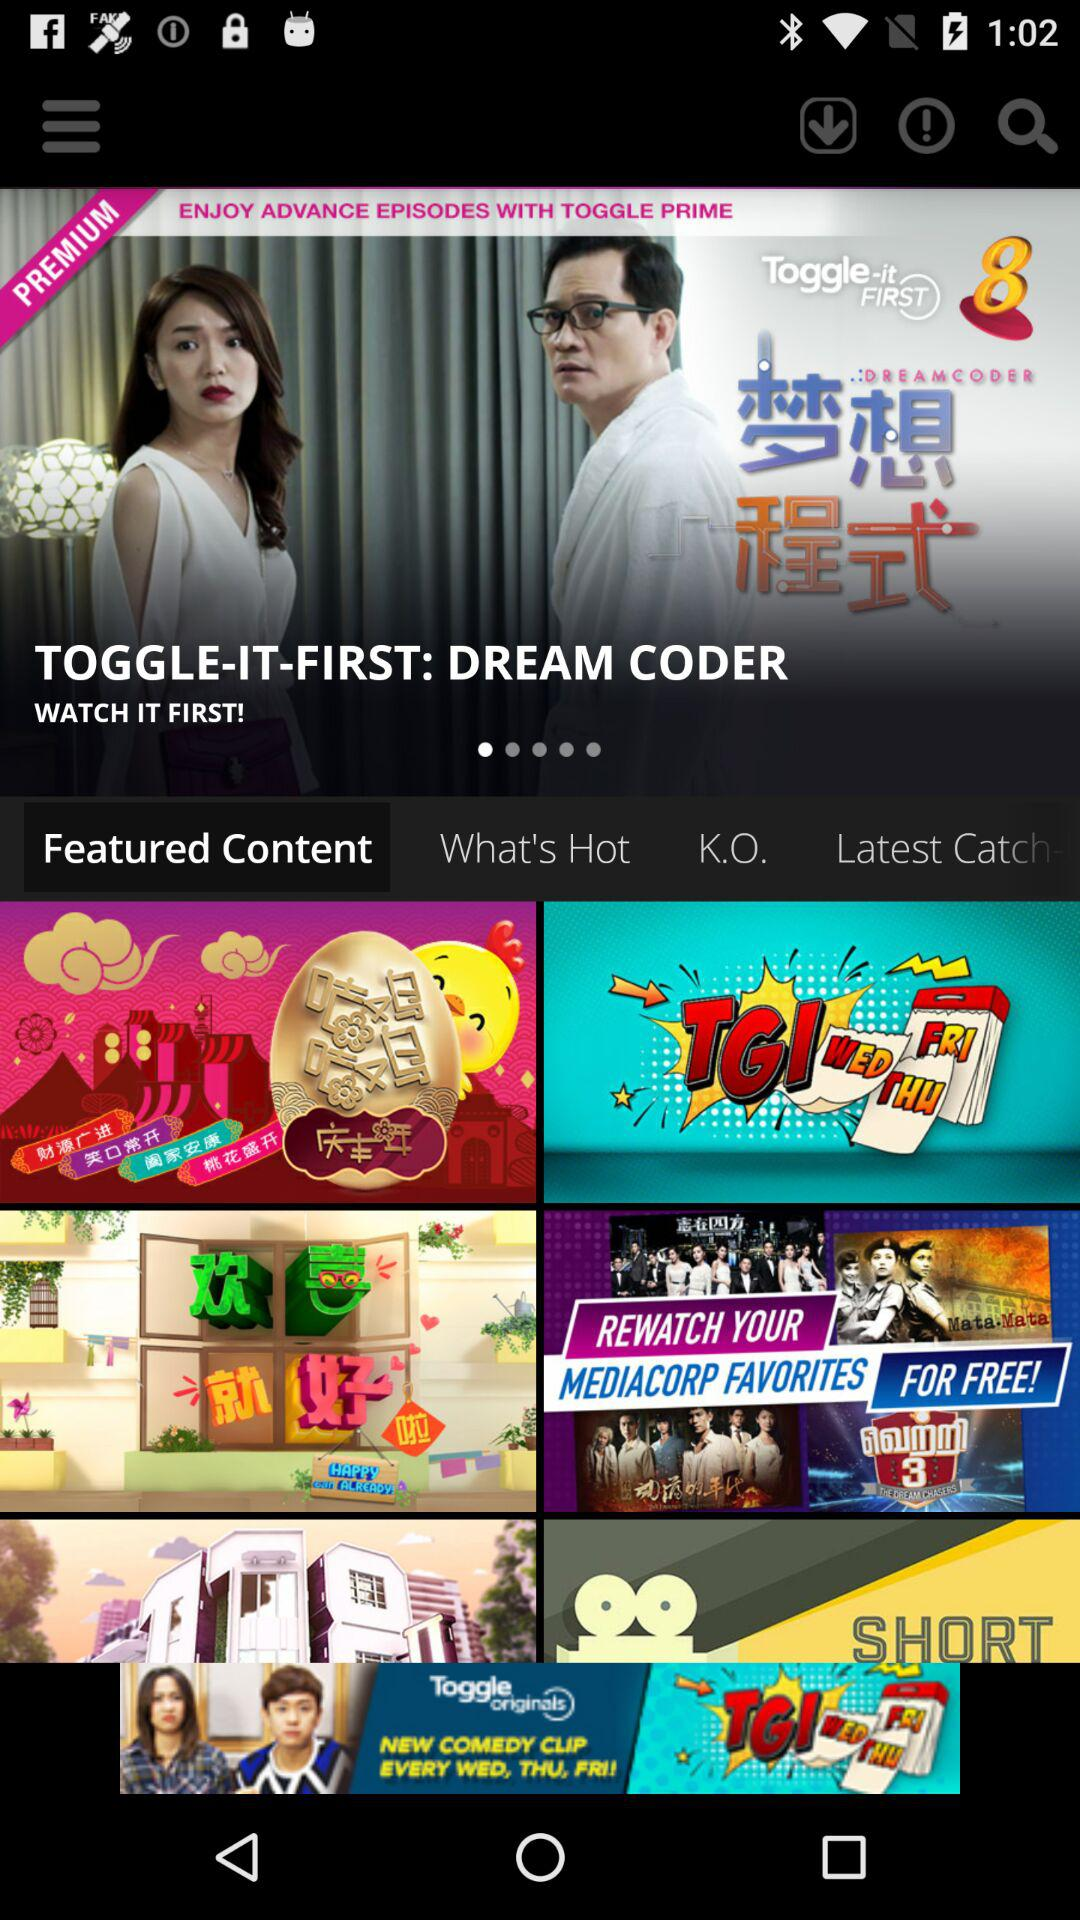How many people have viewed "TOGGLE-IT-FIRST: DREAM CODER"?
When the provided information is insufficient, respond with <no answer>. <no answer> 